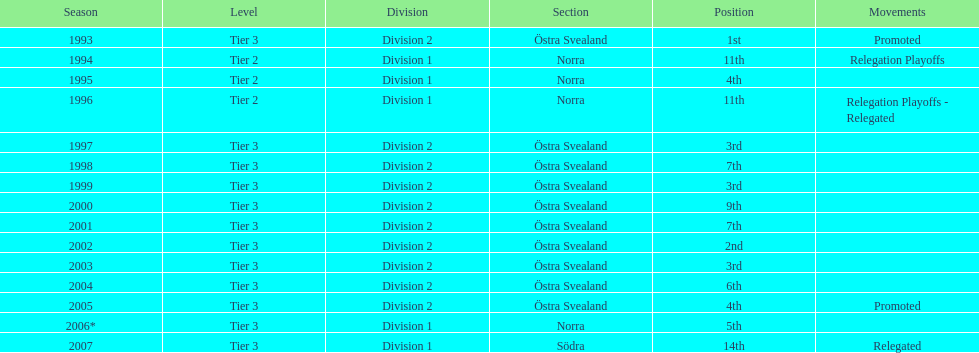They placed third in 2003. when did they place third before that? 1999. 